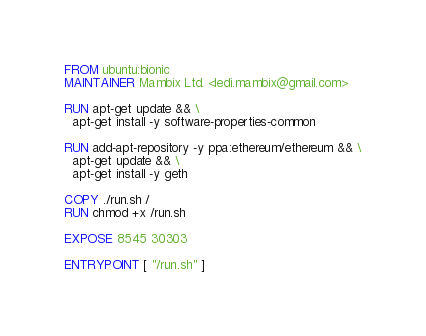Convert code to text. <code><loc_0><loc_0><loc_500><loc_500><_Dockerfile_>FROM ubuntu:bionic
MAINTAINER Mambix Ltd. <ledi.mambix@gmail.com>

RUN apt-get update && \
  apt-get install -y software-properties-common

RUN add-apt-repository -y ppa:ethereum/ethereum && \
  apt-get update && \
  apt-get install -y geth

COPY ./run.sh /
RUN chmod +x /run.sh

EXPOSE 8545 30303

ENTRYPOINT [ "/run.sh" ]
</code> 